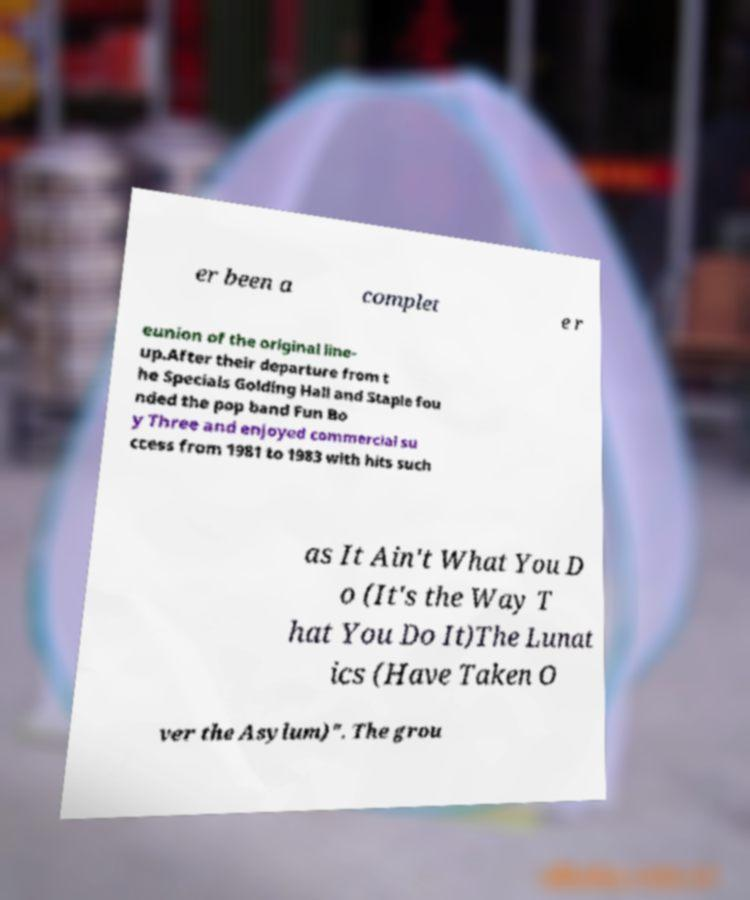What messages or text are displayed in this image? I need them in a readable, typed format. er been a complet e r eunion of the original line- up.After their departure from t he Specials Golding Hall and Staple fou nded the pop band Fun Bo y Three and enjoyed commercial su ccess from 1981 to 1983 with hits such as It Ain't What You D o (It's the Way T hat You Do It)The Lunat ics (Have Taken O ver the Asylum)". The grou 